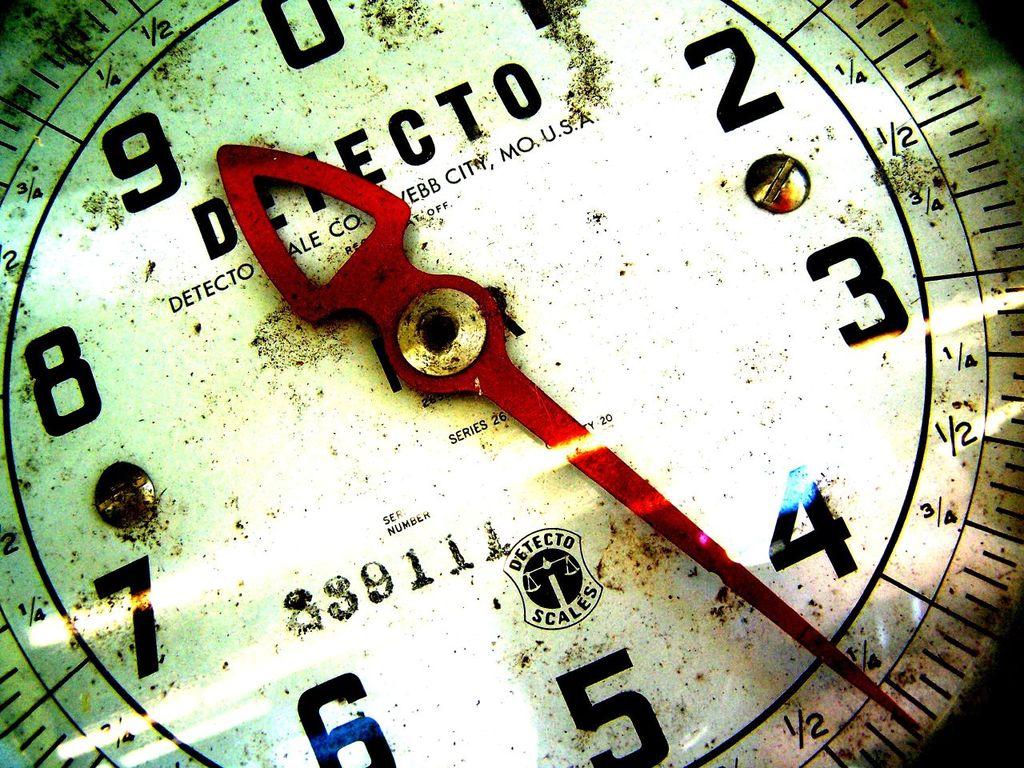What name of clock is this?
Your response must be concise. Detecto. The name of the clock is detecto?
Your response must be concise. Yes. 